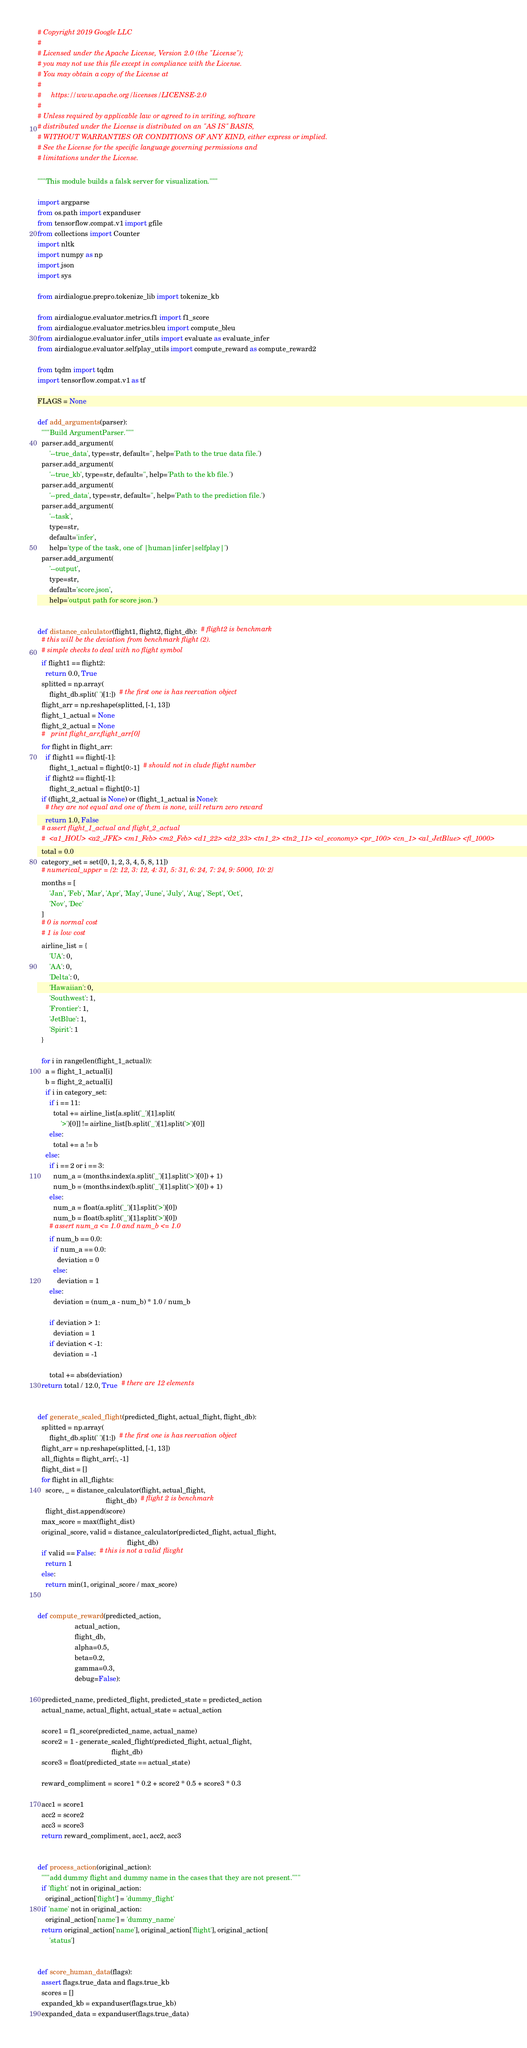<code> <loc_0><loc_0><loc_500><loc_500><_Python_># Copyright 2019 Google LLC
#
# Licensed under the Apache License, Version 2.0 (the "License");
# you may not use this file except in compliance with the License.
# You may obtain a copy of the License at
#
#     https://www.apache.org/licenses/LICENSE-2.0
#
# Unless required by applicable law or agreed to in writing, software
# distributed under the License is distributed on an "AS IS" BASIS,
# WITHOUT WARRANTIES OR CONDITIONS OF ANY KIND, either express or implied.
# See the License for the specific language governing permissions and
# limitations under the License.

"""This module builds a falsk server for visualization."""

import argparse
from os.path import expanduser
from tensorflow.compat.v1 import gfile
from collections import Counter
import nltk
import numpy as np
import json
import sys

from airdialogue.prepro.tokenize_lib import tokenize_kb

from airdialogue.evaluator.metrics.f1 import f1_score
from airdialogue.evaluator.metrics.bleu import compute_bleu
from airdialogue.evaluator.infer_utils import evaluate as evaluate_infer
from airdialogue.evaluator.selfplay_utils import compute_reward as compute_reward2

from tqdm import tqdm
import tensorflow.compat.v1 as tf

FLAGS = None

def add_arguments(parser):
  """Build ArgumentParser."""
  parser.add_argument(
      '--true_data', type=str, default='', help='Path to the true data file.')
  parser.add_argument(
      '--true_kb', type=str, default='', help='Path to the kb file.')
  parser.add_argument(
      '--pred_data', type=str, default='', help='Path to the prediction file.')
  parser.add_argument(
      '--task',
      type=str,
      default='infer',
      help='type of the task, one of |human|infer|selfplay|')
  parser.add_argument(
      '--output',
      type=str,
      default='score.json',
      help='output path for score json.')


def distance_calculator(flight1, flight2, flight_db):  # flight2 is benchmark
  # this will be the deviation from benchmark flight (2).
  # simple checks to deal with no flight symbol
  if flight1 == flight2:
    return 0.0, True
  splitted = np.array(
      flight_db.split(' ')[1:])  # the first one is has reervation object
  flight_arr = np.reshape(splitted, [-1, 13])
  flight_1_actual = None
  flight_2_actual = None
  #   print flight_arr,flight_arr[0]
  for flight in flight_arr:
    if flight1 == flight[-1]:
      flight_1_actual = flight[0:-1]  # should not in clude flight number
    if flight2 == flight[-1]:
      flight_2_actual = flight[0:-1]
  if (flight_2_actual is None) or (flight_1_actual is None):
    # they are not equal and one of them is none, will return zero reward
    return 1.0, False
  # assert flight_1_actual and flight_2_actual
  #  <a1_HOU> <a2_JFK> <m1_Feb> <m2_Feb> <d1_22> <d2_23> <tn1_2> <tn2_11> <cl_economy> <pr_100> <cn_1> <al_JetBlue> <fl_1000>
  total = 0.0
  category_set = set([0, 1, 2, 3, 4, 5, 8, 11])
  # numerical_upper = {2: 12, 3: 12, 4: 31, 5: 31, 6: 24, 7: 24, 9: 5000, 10: 2}
  months = [
      'Jan', 'Feb', 'Mar', 'Apr', 'May', 'June', 'July', 'Aug', 'Sept', 'Oct',
      'Nov', 'Dec'
  ]
  # 0 is normal cost
  # 1 is low cost
  airline_list = {
      'UA': 0,
      'AA': 0,
      'Delta': 0,
      'Hawaiian': 0,
      'Southwest': 1,
      'Frontier': 1,
      'JetBlue': 1,
      'Spirit': 1
  }

  for i in range(len(flight_1_actual)):
    a = flight_1_actual[i]
    b = flight_2_actual[i]
    if i in category_set:
      if i == 11:
        total += airline_list[a.split('_')[1].split(
            '>')[0]] != airline_list[b.split('_')[1].split('>')[0]]
      else:
        total += a != b
    else:
      if i == 2 or i == 3:
        num_a = (months.index(a.split('_')[1].split('>')[0]) + 1)
        num_b = (months.index(b.split('_')[1].split('>')[0]) + 1)
      else:
        num_a = float(a.split('_')[1].split('>')[0])
        num_b = float(b.split('_')[1].split('>')[0])
      # assert num_a <= 1.0 and num_b <= 1.0
      if num_b == 0.0:
        if num_a == 0.0:
          deviation = 0
        else:
          deviation = 1
      else:
        deviation = (num_a - num_b) * 1.0 / num_b

      if deviation > 1:
        deviation = 1
      if deviation < -1:
        deviation = -1

      total += abs(deviation)
  return total / 12.0, True  # there are 12 elements


def generate_scaled_flight(predicted_flight, actual_flight, flight_db):
  splitted = np.array(
      flight_db.split(' ')[1:])  # the first one is has reervation object
  flight_arr = np.reshape(splitted, [-1, 13])
  all_flights = flight_arr[:, -1]
  flight_dist = []
  for flight in all_flights:
    score, _ = distance_calculator(flight, actual_flight,
                                   flight_db)  # flight 2 is benchmark
    flight_dist.append(score)
  max_score = max(flight_dist)
  original_score, valid = distance_calculator(predicted_flight, actual_flight,
                                              flight_db)
  if valid == False:  # this is not a valid flivght
    return 1
  else:
    return min(1, original_score / max_score)


def compute_reward(predicted_action,
                   actual_action,
                   flight_db,
                   alpha=0.5,
                   beta=0.2,
                   gamma=0.3,
                   debug=False):

  predicted_name, predicted_flight, predicted_state = predicted_action
  actual_name, actual_flight, actual_state = actual_action

  score1 = f1_score(predicted_name, actual_name)
  score2 = 1 - generate_scaled_flight(predicted_flight, actual_flight,
                                      flight_db)
  score3 = float(predicted_state == actual_state)

  reward_compliment = score1 * 0.2 + score2 * 0.5 + score3 * 0.3

  acc1 = score1
  acc2 = score2
  acc3 = score3
  return reward_compliment, acc1, acc2, acc3


def process_action(original_action):
  """add dummy flight and dummy name in the cases that they are not present."""
  if 'flight' not in original_action:
    original_action['flight'] = 'dummy_flight'
  if 'name' not in original_action:
    original_action['name'] = 'dummy_name'
  return original_action['name'], original_action['flight'], original_action[
      'status']


def score_human_data(flags):
  assert flags.true_data and flags.true_kb
  scores = []
  expanded_kb = expanduser(flags.true_kb)
  expanded_data = expanduser(flags.true_data)</code> 